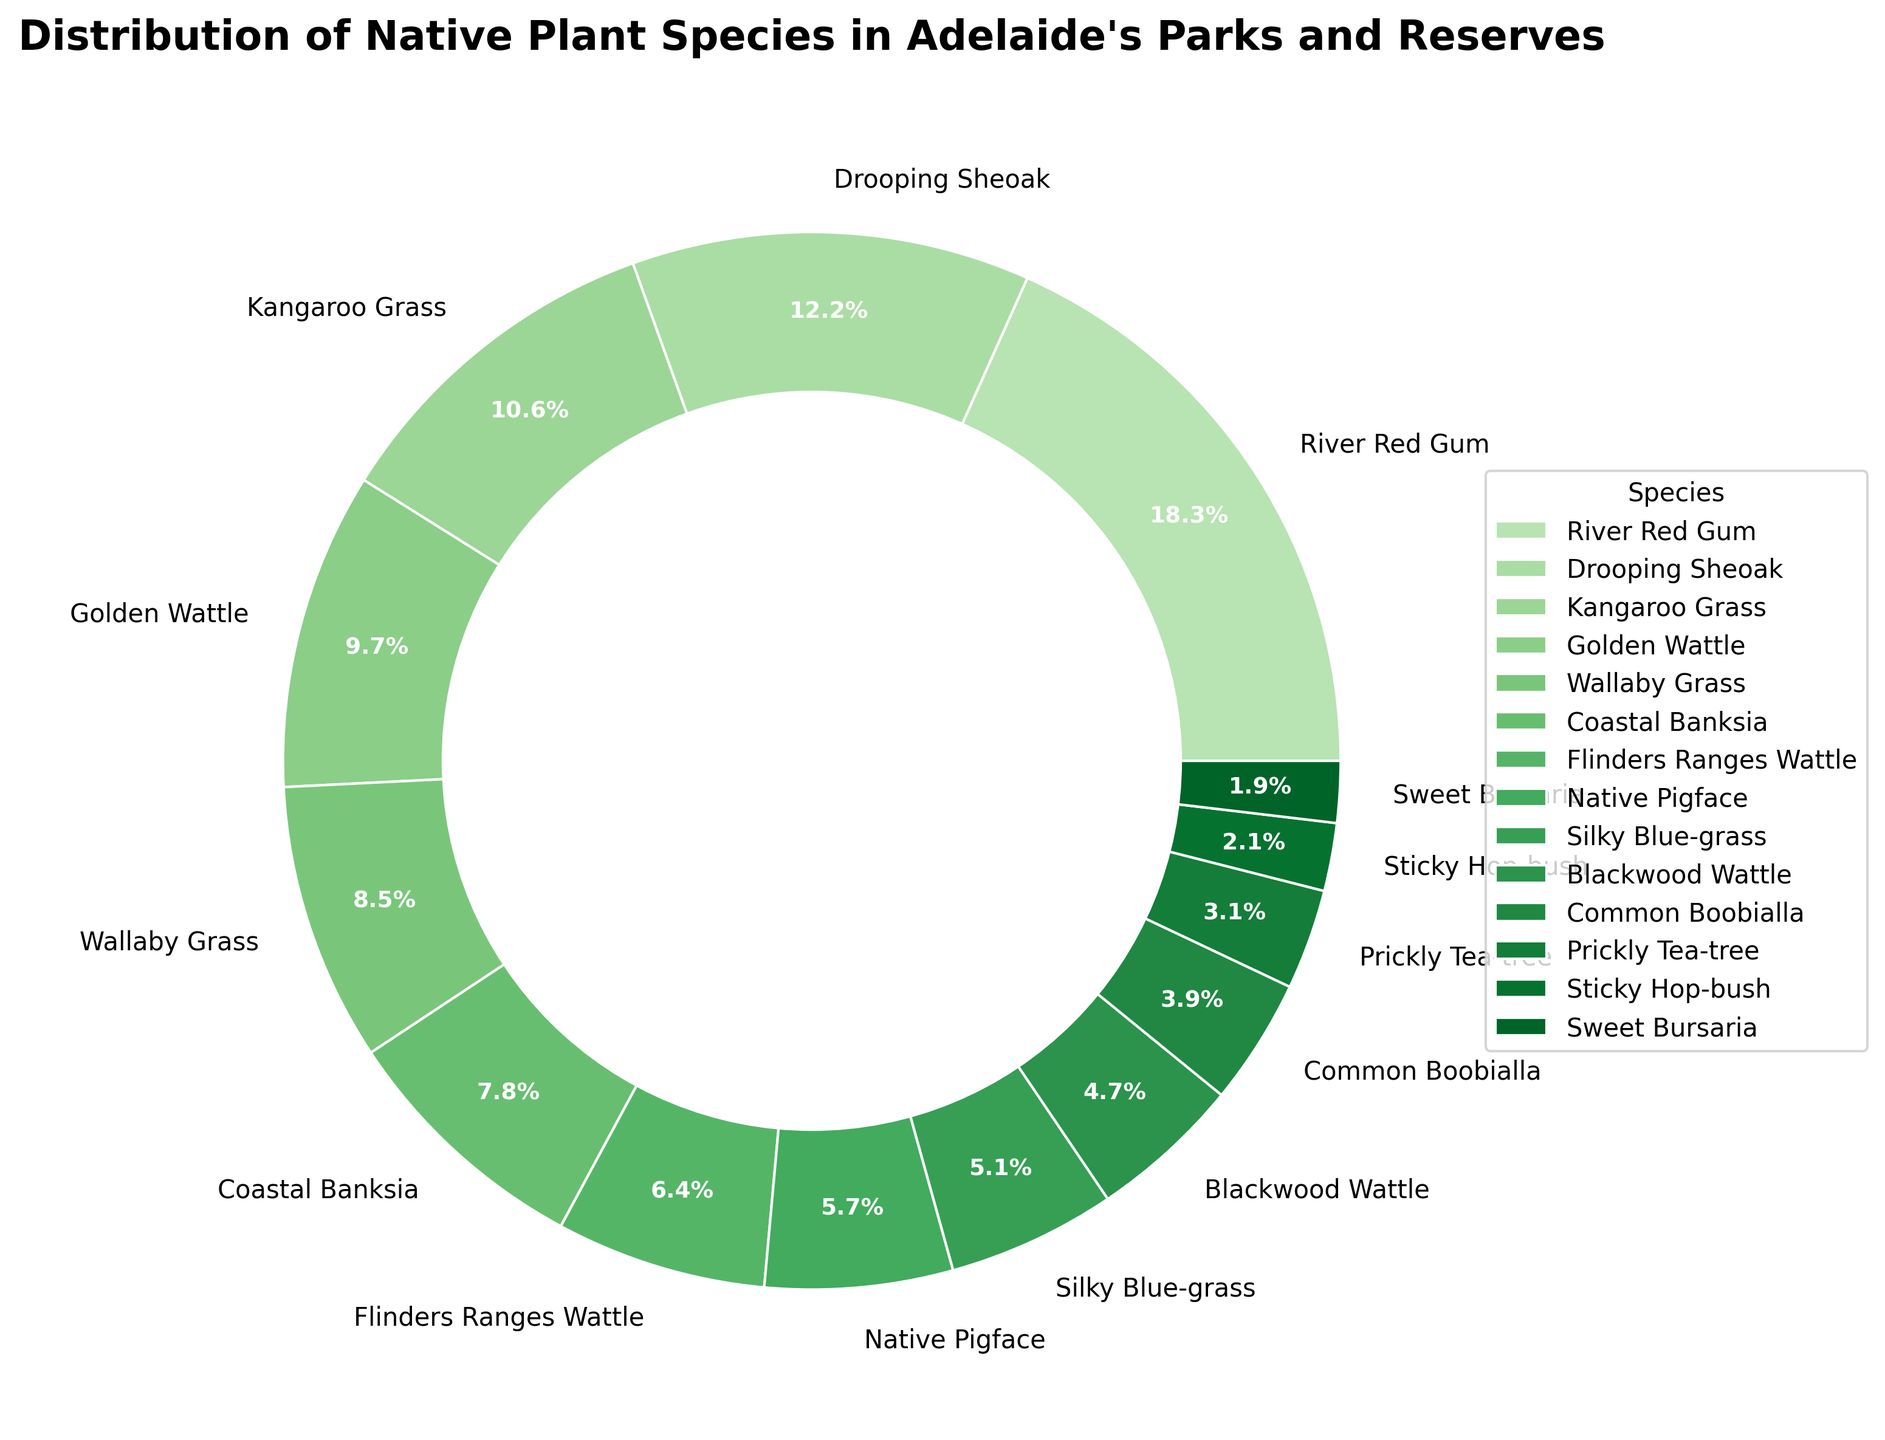What is the most common native plant species in Adelaide's parks and reserves? To find the most common plant species, look for the largest wedge in the pie chart and its corresponding label.
Answer: River Red Gum Which two species have the closest percentage representation? Identify the two wedges that look the closest in size and compare their labels and percentages. The closest ones are Drooping Sheoak (12.3%) and Kangaroo Grass (10.7%).
Answer: Drooping Sheoak and Kangaroo Grass How much more common is the River Red Gum compared to Common Boobialla? Find the percentage for both species: River Red Gum (18.5%) and Common Boobialla (3.9%). Calculate the difference: 18.5 - 3.9 = 14.6%.
Answer: 14.6% What are the total percentages of the three least common species combined? Identify the three smallest wedges and sum their percentages: Prickly Tea-tree (3.1%), Sticky Hop-bush (2.1%), and Sweet Bursaria (1.9%). The total is 3.1 + 2.1 + 1.9 = 7.1%.
Answer: 7.1% Which species’ wedge is located immediately after the Coastal Banksia wedge when moving clockwise? Find the wedge labeled 'Coastal Banksia' and look at the label of the next wedge in a clockwise direction.
Answer: Flinders Ranges Wattle How many species have a percentage greater than 8%? Count the number of wedges with percentages greater than 8%. The species are River Red Gum (18.5%), Drooping Sheoak (12.3%), Kangaroo Grass (10.7%), Golden Wattle (9.8%), and Wallaby Grass (8.6%).
Answer: Five Are there more species with percentages above or below 5%? Count the number of species with percentages above 5% and those below 5%. Ones above 5%: River Red Gum, Drooping Sheoak, Kangaroo Grass, Golden Wattle, Wallaby Grass, Coastal Banksia, Flinders Ranges Wattle, Native Pigface, Silky Blue-grass (9 species). Ones below 5%: Blackwood Wattle, Common Boobialla, Prickly Tea-tree, Sticky Hop-bush, Sweet Bursaria (5 species).
Answer: Above 